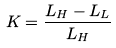<formula> <loc_0><loc_0><loc_500><loc_500>K = \frac { L _ { H } - L _ { L } } { L _ { H } }</formula> 